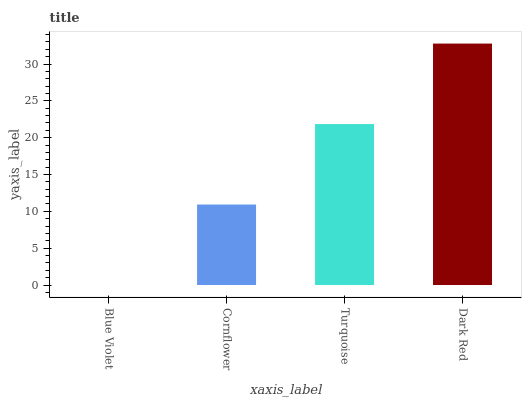Is Blue Violet the minimum?
Answer yes or no. Yes. Is Dark Red the maximum?
Answer yes or no. Yes. Is Cornflower the minimum?
Answer yes or no. No. Is Cornflower the maximum?
Answer yes or no. No. Is Cornflower greater than Blue Violet?
Answer yes or no. Yes. Is Blue Violet less than Cornflower?
Answer yes or no. Yes. Is Blue Violet greater than Cornflower?
Answer yes or no. No. Is Cornflower less than Blue Violet?
Answer yes or no. No. Is Turquoise the high median?
Answer yes or no. Yes. Is Cornflower the low median?
Answer yes or no. Yes. Is Blue Violet the high median?
Answer yes or no. No. Is Blue Violet the low median?
Answer yes or no. No. 